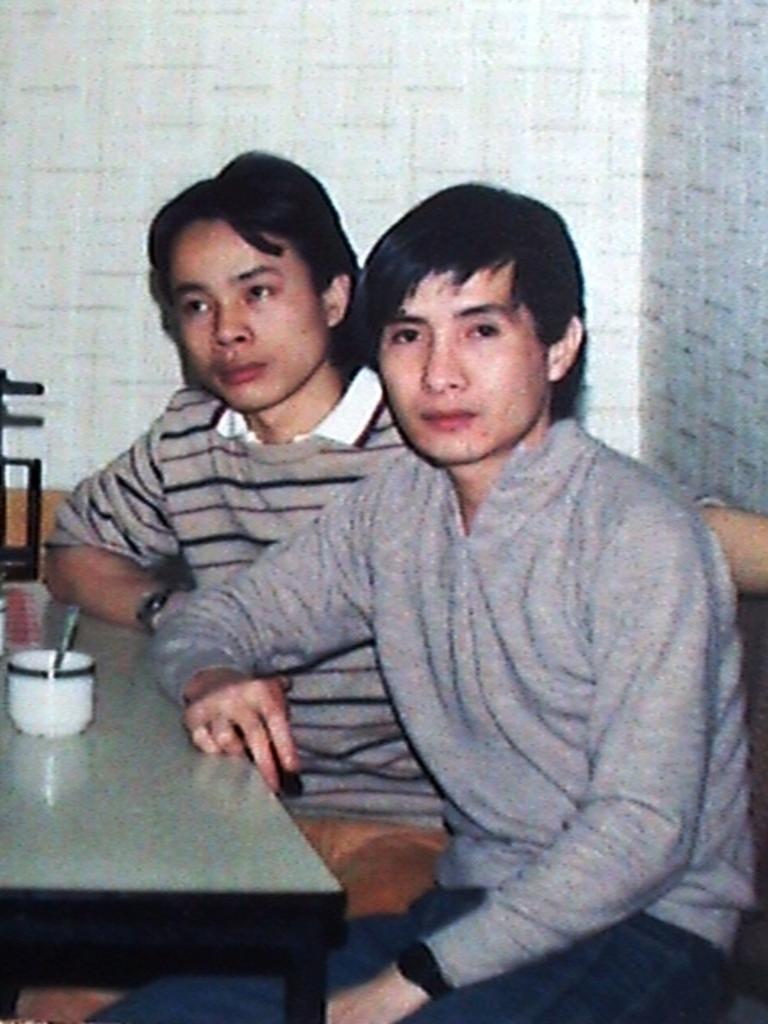How many people are in the image? There are two men in the image. What are the men doing in the image? The men are sitting on chairs. What is in front of the men? There is a table in front of the men. What object can be seen on the table? A cup is present on the table. What type of hen is sitting on the table next to the cup? There is no hen present in the image; only the two men, chairs, table, and cup are visible. 